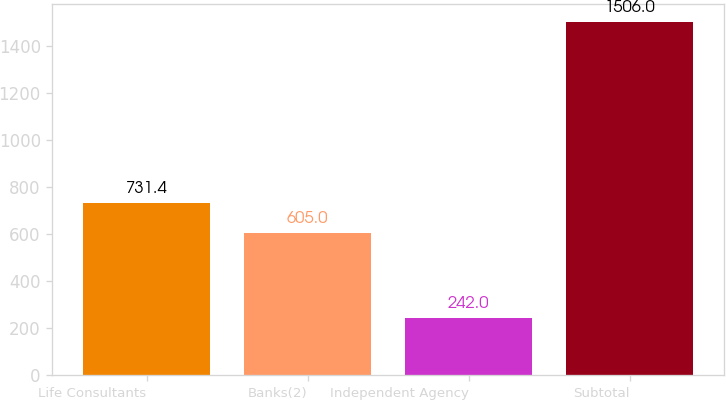Convert chart. <chart><loc_0><loc_0><loc_500><loc_500><bar_chart><fcel>Life Consultants<fcel>Banks(2)<fcel>Independent Agency<fcel>Subtotal<nl><fcel>731.4<fcel>605<fcel>242<fcel>1506<nl></chart> 